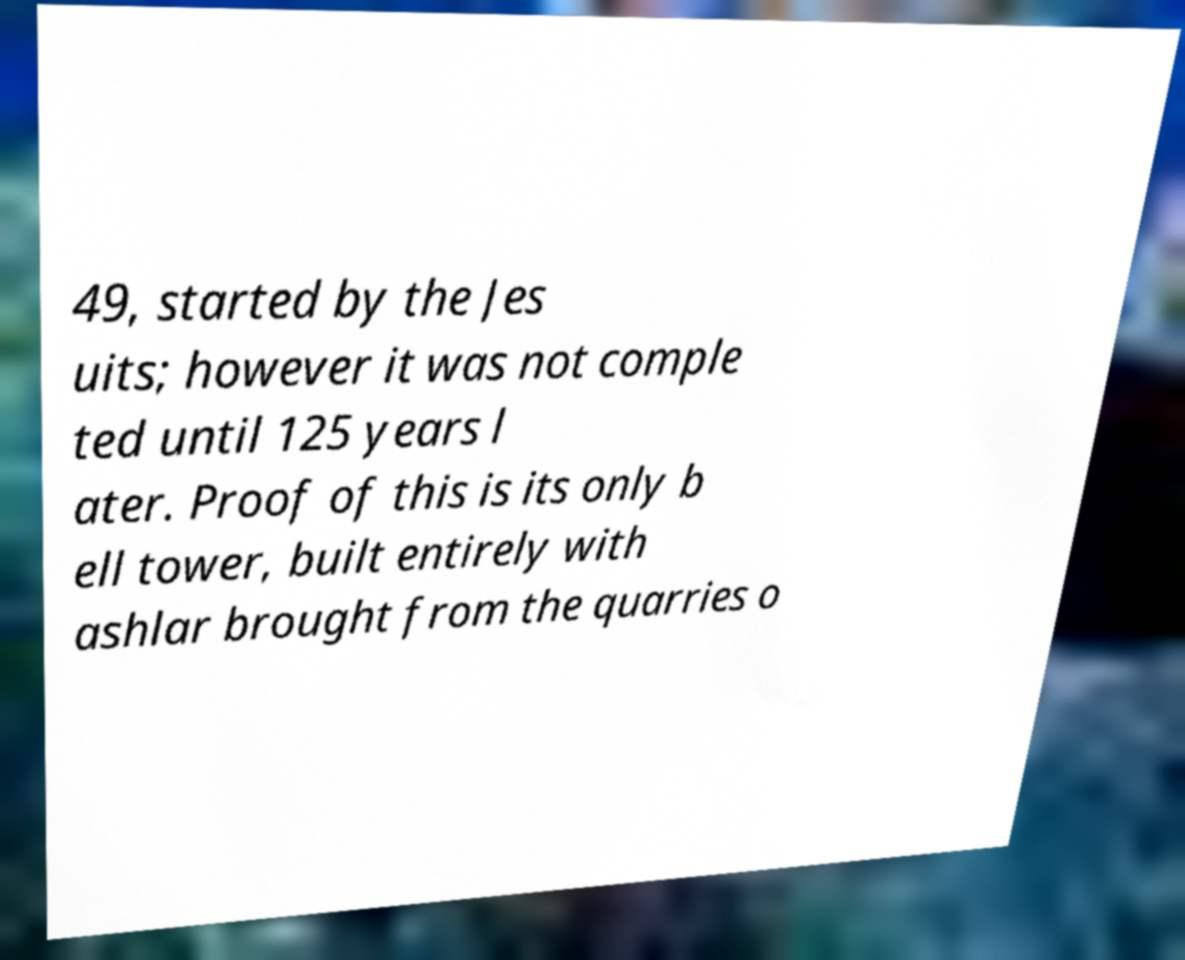Could you extract and type out the text from this image? 49, started by the Jes uits; however it was not comple ted until 125 years l ater. Proof of this is its only b ell tower, built entirely with ashlar brought from the quarries o 